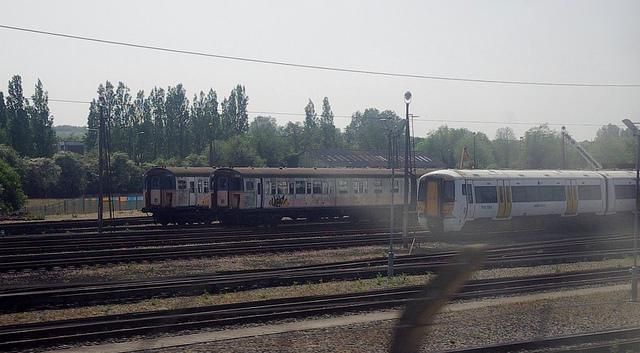Are these trains in competition?
Short answer required. No. Could an airplane easily land here?
Short answer required. No. How are theses trains being powered?
Keep it brief. Electricity. 